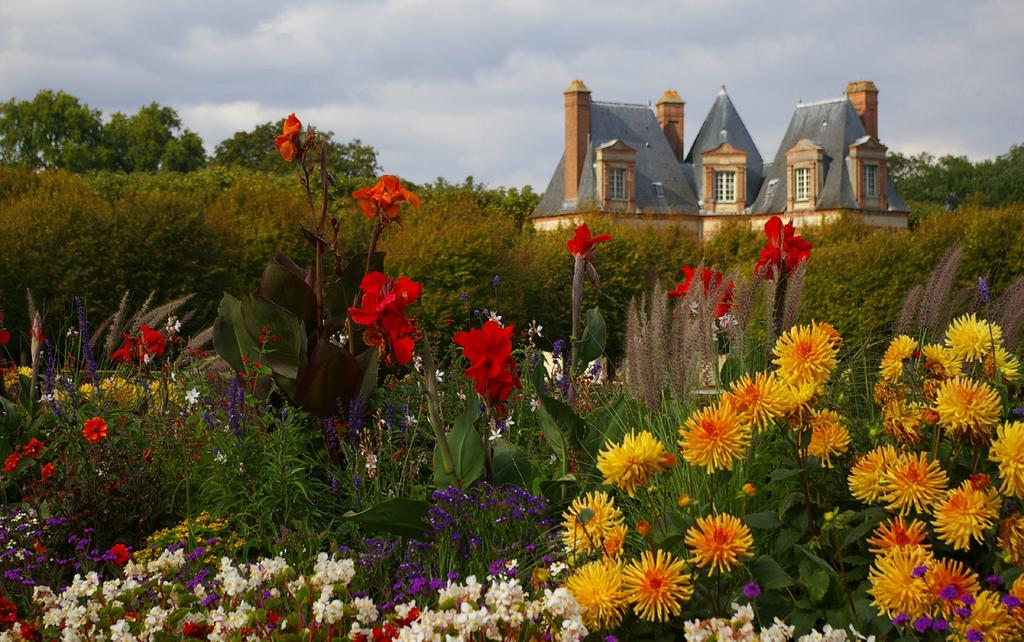What type of living organisms can be seen in the image? Plants with flowers are visible in the image. What can be seen in the background of the image? There is a house and trees in the background of the image. What is visible at the top of the image? The sky is visible at the top of the image. What time of day is it in the image, and how many mice are visible? The time of day cannot be determined from the image, and there are no mice present in the image. 